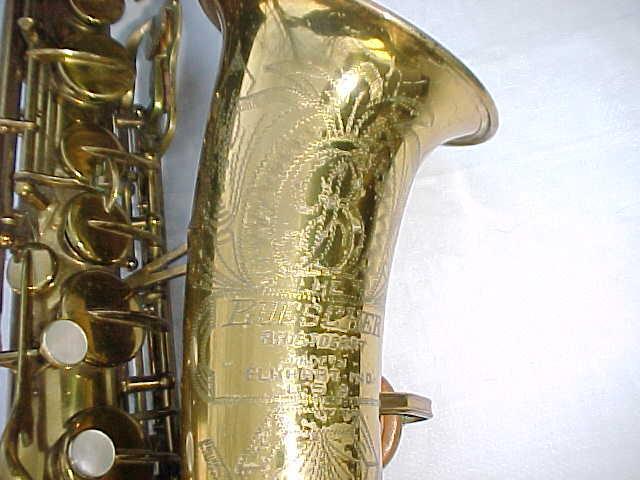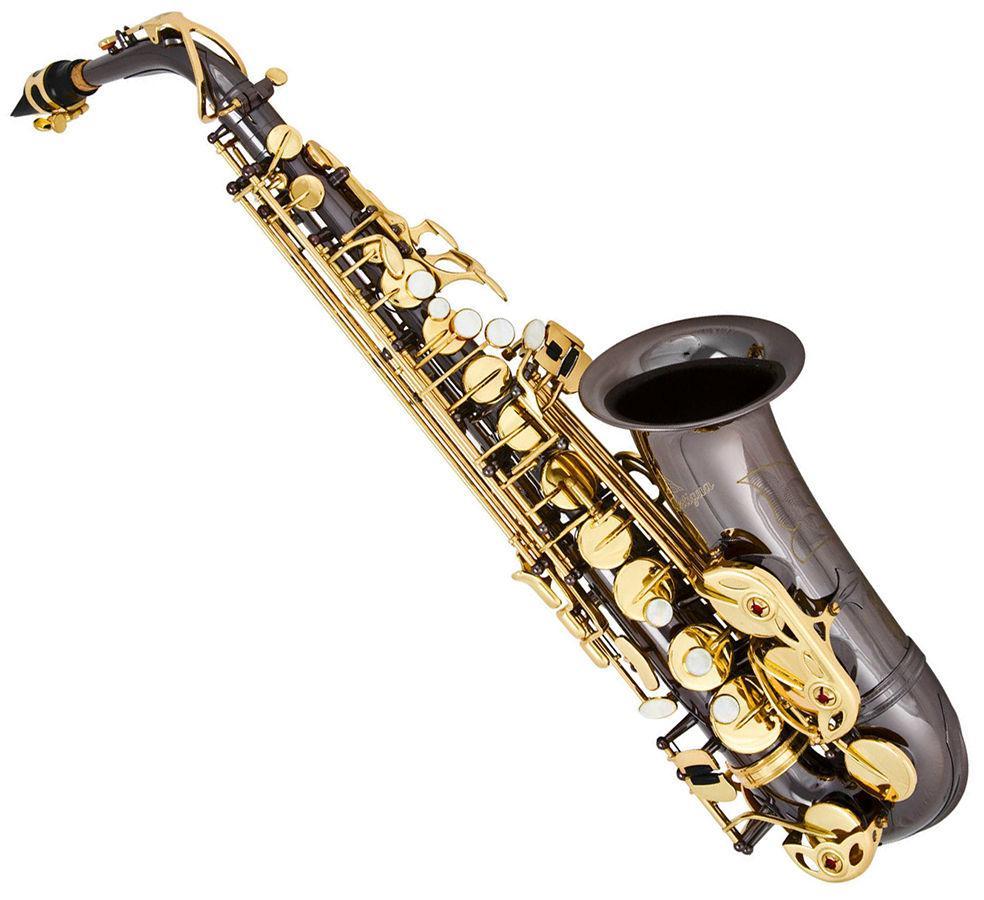The first image is the image on the left, the second image is the image on the right. Considering the images on both sides, is "One of the sax's is inside its case." valid? Answer yes or no. No. The first image is the image on the left, the second image is the image on the right. Evaluate the accuracy of this statement regarding the images: "The right image shows a dark saxophone with gold buttons displayed diagonally, with its mouthpiece at the upper left and its bell upturned.". Is it true? Answer yes or no. Yes. 